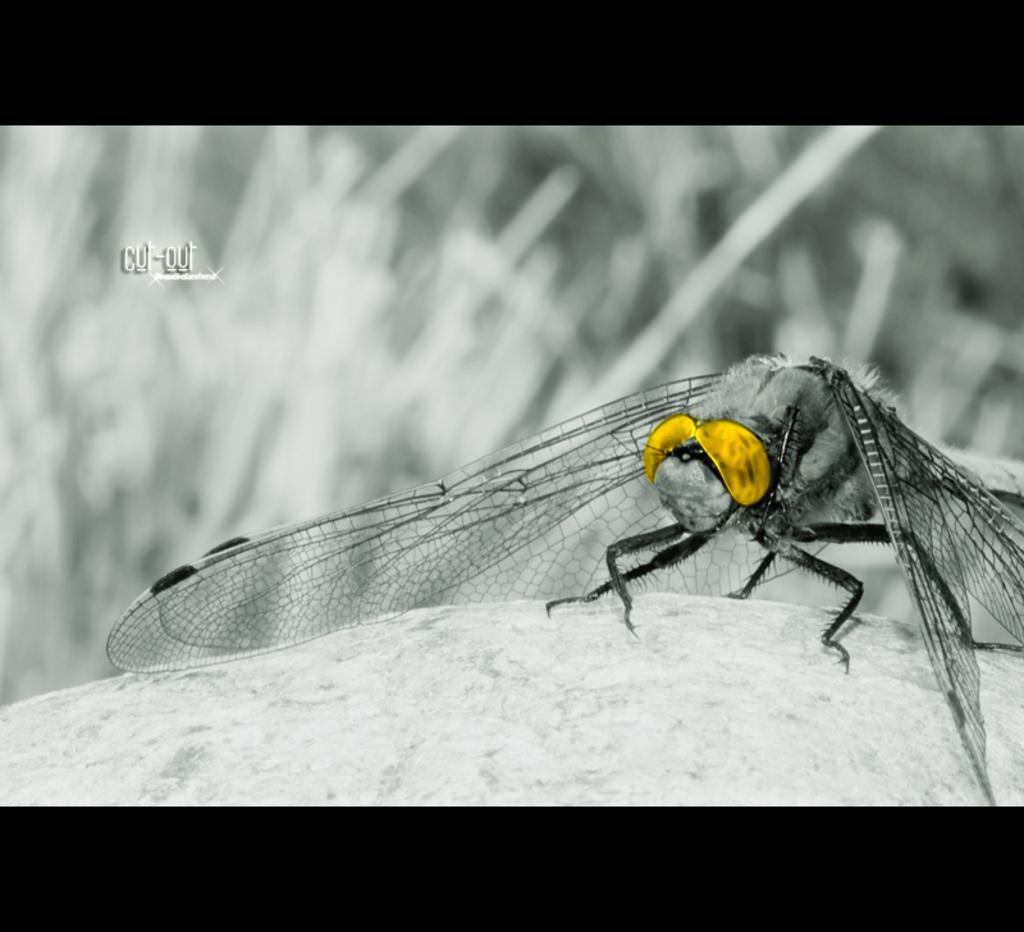How would you summarize this image in a sentence or two? In this image we can see dragonfly which is of color silver and gold. 